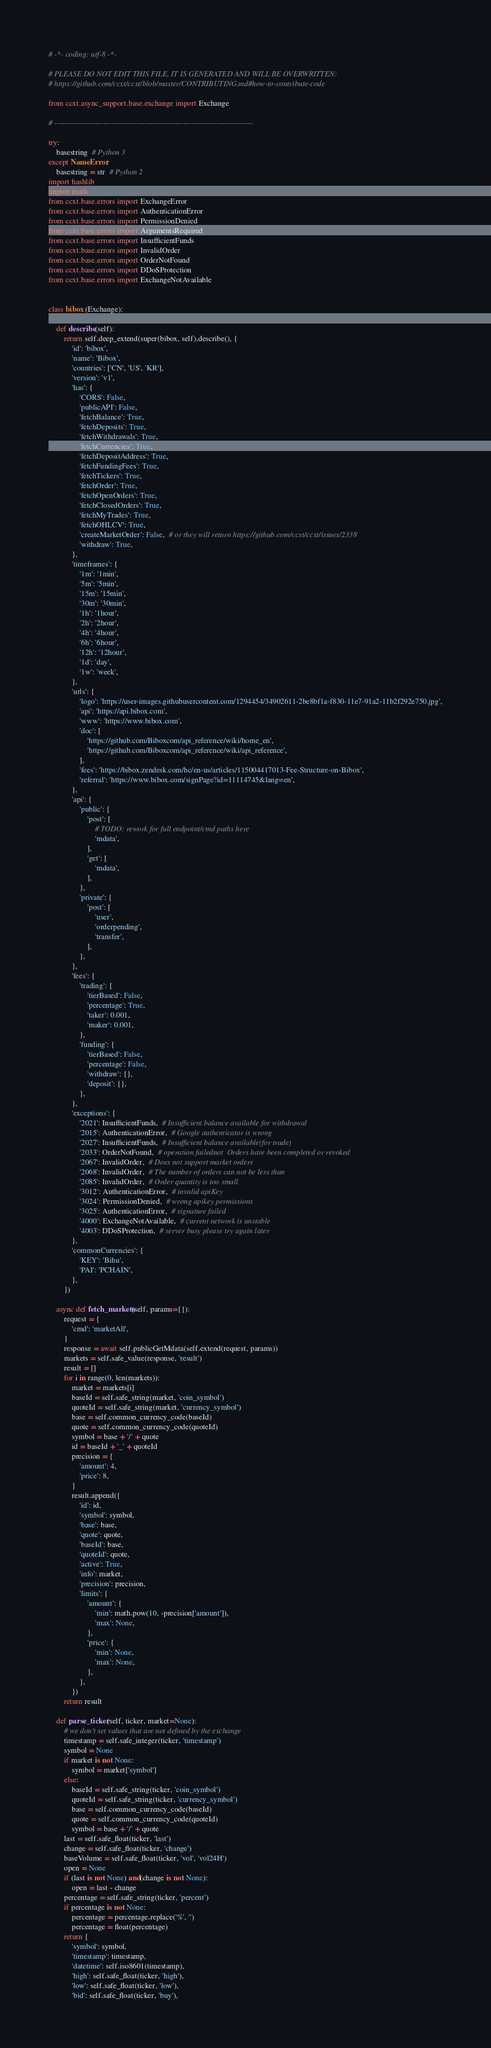<code> <loc_0><loc_0><loc_500><loc_500><_Python_># -*- coding: utf-8 -*-

# PLEASE DO NOT EDIT THIS FILE, IT IS GENERATED AND WILL BE OVERWRITTEN:
# https://github.com/ccxt/ccxt/blob/master/CONTRIBUTING.md#how-to-contribute-code

from ccxt.async_support.base.exchange import Exchange

# -----------------------------------------------------------------------------

try:
    basestring  # Python 3
except NameError:
    basestring = str  # Python 2
import hashlib
import math
from ccxt.base.errors import ExchangeError
from ccxt.base.errors import AuthenticationError
from ccxt.base.errors import PermissionDenied
from ccxt.base.errors import ArgumentsRequired
from ccxt.base.errors import InsufficientFunds
from ccxt.base.errors import InvalidOrder
from ccxt.base.errors import OrderNotFound
from ccxt.base.errors import DDoSProtection
from ccxt.base.errors import ExchangeNotAvailable


class bibox (Exchange):

    def describe(self):
        return self.deep_extend(super(bibox, self).describe(), {
            'id': 'bibox',
            'name': 'Bibox',
            'countries': ['CN', 'US', 'KR'],
            'version': 'v1',
            'has': {
                'CORS': False,
                'publicAPI': False,
                'fetchBalance': True,
                'fetchDeposits': True,
                'fetchWithdrawals': True,
                'fetchCurrencies': True,
                'fetchDepositAddress': True,
                'fetchFundingFees': True,
                'fetchTickers': True,
                'fetchOrder': True,
                'fetchOpenOrders': True,
                'fetchClosedOrders': True,
                'fetchMyTrades': True,
                'fetchOHLCV': True,
                'createMarketOrder': False,  # or they will return https://github.com/ccxt/ccxt/issues/2338
                'withdraw': True,
            },
            'timeframes': {
                '1m': '1min',
                '5m': '5min',
                '15m': '15min',
                '30m': '30min',
                '1h': '1hour',
                '2h': '2hour',
                '4h': '4hour',
                '6h': '6hour',
                '12h': '12hour',
                '1d': 'day',
                '1w': 'week',
            },
            'urls': {
                'logo': 'https://user-images.githubusercontent.com/1294454/34902611-2be8bf1a-f830-11e7-91a2-11b2f292e750.jpg',
                'api': 'https://api.bibox.com',
                'www': 'https://www.bibox.com',
                'doc': [
                    'https://github.com/Biboxcom/api_reference/wiki/home_en',
                    'https://github.com/Biboxcom/api_reference/wiki/api_reference',
                ],
                'fees': 'https://bibox.zendesk.com/hc/en-us/articles/115004417013-Fee-Structure-on-Bibox',
                'referral': 'https://www.bibox.com/signPage?id=11114745&lang=en',
            },
            'api': {
                'public': {
                    'post': [
                        # TODO: rework for full endpoint/cmd paths here
                        'mdata',
                    ],
                    'get': [
                        'mdata',
                    ],
                },
                'private': {
                    'post': [
                        'user',
                        'orderpending',
                        'transfer',
                    ],
                },
            },
            'fees': {
                'trading': {
                    'tierBased': False,
                    'percentage': True,
                    'taker': 0.001,
                    'maker': 0.001,
                },
                'funding': {
                    'tierBased': False,
                    'percentage': False,
                    'withdraw': {},
                    'deposit': {},
                },
            },
            'exceptions': {
                '2021': InsufficientFunds,  # Insufficient balance available for withdrawal
                '2015': AuthenticationError,  # Google authenticator is wrong
                '2027': InsufficientFunds,  # Insufficient balance available(for trade)
                '2033': OrderNotFound,  # operation failednot  Orders have been completed or revoked
                '2067': InvalidOrder,  # Does not support market orders
                '2068': InvalidOrder,  # The number of orders can not be less than
                '2085': InvalidOrder,  # Order quantity is too small
                '3012': AuthenticationError,  # invalid apiKey
                '3024': PermissionDenied,  # wrong apikey permissions
                '3025': AuthenticationError,  # signature failed
                '4000': ExchangeNotAvailable,  # current network is unstable
                '4003': DDoSProtection,  # server busy please try again later
            },
            'commonCurrencies': {
                'KEY': 'Bihu',
                'PAI': 'PCHAIN',
            },
        })

    async def fetch_markets(self, params={}):
        request = {
            'cmd': 'marketAll',
        }
        response = await self.publicGetMdata(self.extend(request, params))
        markets = self.safe_value(response, 'result')
        result = []
        for i in range(0, len(markets)):
            market = markets[i]
            baseId = self.safe_string(market, 'coin_symbol')
            quoteId = self.safe_string(market, 'currency_symbol')
            base = self.common_currency_code(baseId)
            quote = self.common_currency_code(quoteId)
            symbol = base + '/' + quote
            id = baseId + '_' + quoteId
            precision = {
                'amount': 4,
                'price': 8,
            }
            result.append({
                'id': id,
                'symbol': symbol,
                'base': base,
                'quote': quote,
                'baseId': base,
                'quoteId': quote,
                'active': True,
                'info': market,
                'precision': precision,
                'limits': {
                    'amount': {
                        'min': math.pow(10, -precision['amount']),
                        'max': None,
                    },
                    'price': {
                        'min': None,
                        'max': None,
                    },
                },
            })
        return result

    def parse_ticker(self, ticker, market=None):
        # we don't set values that are not defined by the exchange
        timestamp = self.safe_integer(ticker, 'timestamp')
        symbol = None
        if market is not None:
            symbol = market['symbol']
        else:
            baseId = self.safe_string(ticker, 'coin_symbol')
            quoteId = self.safe_string(ticker, 'currency_symbol')
            base = self.common_currency_code(baseId)
            quote = self.common_currency_code(quoteId)
            symbol = base + '/' + quote
        last = self.safe_float(ticker, 'last')
        change = self.safe_float(ticker, 'change')
        baseVolume = self.safe_float(ticker, 'vol', 'vol24H')
        open = None
        if (last is not None) and(change is not None):
            open = last - change
        percentage = self.safe_string(ticker, 'percent')
        if percentage is not None:
            percentage = percentage.replace('%', '')
            percentage = float(percentage)
        return {
            'symbol': symbol,
            'timestamp': timestamp,
            'datetime': self.iso8601(timestamp),
            'high': self.safe_float(ticker, 'high'),
            'low': self.safe_float(ticker, 'low'),
            'bid': self.safe_float(ticker, 'buy'),</code> 